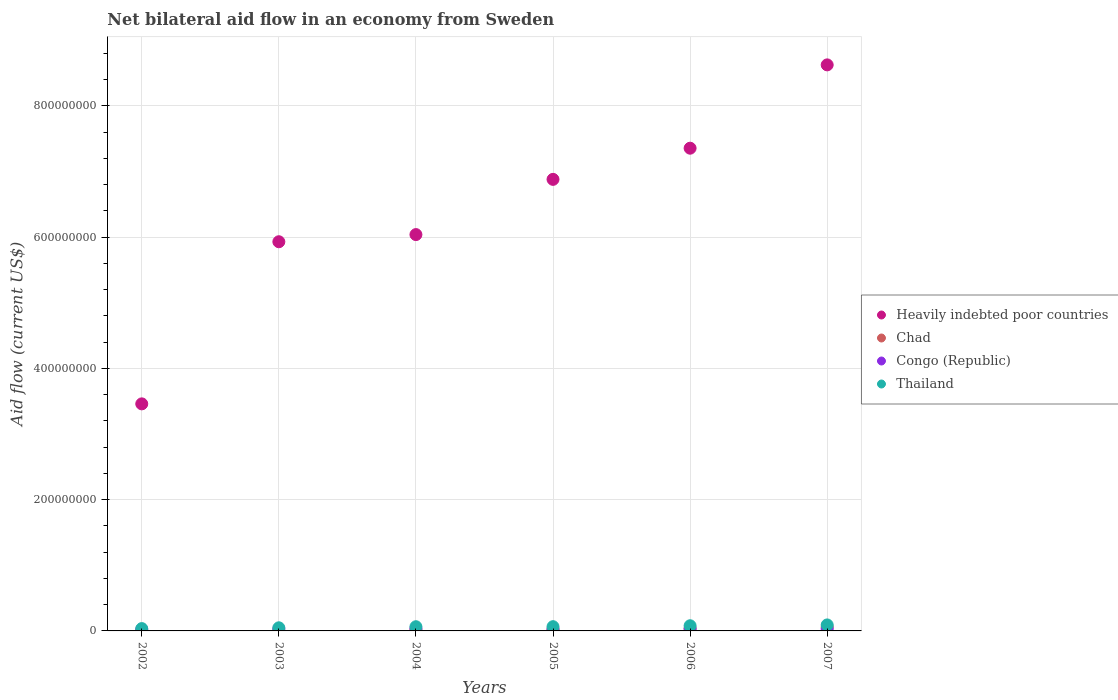How many different coloured dotlines are there?
Your answer should be very brief. 4. Is the number of dotlines equal to the number of legend labels?
Make the answer very short. No. What is the net bilateral aid flow in Chad in 2007?
Make the answer very short. 5.87e+06. Across all years, what is the maximum net bilateral aid flow in Congo (Republic)?
Make the answer very short. 3.56e+06. Across all years, what is the minimum net bilateral aid flow in Heavily indebted poor countries?
Give a very brief answer. 3.46e+08. In which year was the net bilateral aid flow in Congo (Republic) maximum?
Offer a very short reply. 2004. What is the total net bilateral aid flow in Chad in the graph?
Provide a short and direct response. 1.38e+07. What is the difference between the net bilateral aid flow in Congo (Republic) in 2002 and that in 2006?
Offer a very short reply. -1.04e+06. What is the difference between the net bilateral aid flow in Heavily indebted poor countries in 2003 and the net bilateral aid flow in Congo (Republic) in 2005?
Give a very brief answer. 5.91e+08. What is the average net bilateral aid flow in Heavily indebted poor countries per year?
Your response must be concise. 6.38e+08. In the year 2003, what is the difference between the net bilateral aid flow in Thailand and net bilateral aid flow in Heavily indebted poor countries?
Ensure brevity in your answer.  -5.88e+08. In how many years, is the net bilateral aid flow in Chad greater than 800000000 US$?
Offer a very short reply. 0. What is the ratio of the net bilateral aid flow in Congo (Republic) in 2005 to that in 2007?
Offer a terse response. 0.7. Is the net bilateral aid flow in Chad in 2003 less than that in 2006?
Your answer should be compact. Yes. Is the difference between the net bilateral aid flow in Thailand in 2006 and 2007 greater than the difference between the net bilateral aid flow in Heavily indebted poor countries in 2006 and 2007?
Offer a terse response. Yes. What is the difference between the highest and the second highest net bilateral aid flow in Thailand?
Your answer should be compact. 1.25e+06. What is the difference between the highest and the lowest net bilateral aid flow in Thailand?
Ensure brevity in your answer.  5.58e+06. Does the net bilateral aid flow in Chad monotonically increase over the years?
Your response must be concise. Yes. Is the net bilateral aid flow in Heavily indebted poor countries strictly less than the net bilateral aid flow in Congo (Republic) over the years?
Provide a short and direct response. No. How many years are there in the graph?
Provide a succinct answer. 6. Does the graph contain any zero values?
Your answer should be very brief. Yes. Does the graph contain grids?
Your answer should be compact. Yes. Where does the legend appear in the graph?
Give a very brief answer. Center right. How many legend labels are there?
Your response must be concise. 4. How are the legend labels stacked?
Keep it short and to the point. Vertical. What is the title of the graph?
Give a very brief answer. Net bilateral aid flow in an economy from Sweden. Does "Niger" appear as one of the legend labels in the graph?
Provide a short and direct response. No. What is the label or title of the X-axis?
Your answer should be very brief. Years. What is the label or title of the Y-axis?
Your answer should be compact. Aid flow (current US$). What is the Aid flow (current US$) of Heavily indebted poor countries in 2002?
Provide a succinct answer. 3.46e+08. What is the Aid flow (current US$) in Congo (Republic) in 2002?
Offer a very short reply. 2.16e+06. What is the Aid flow (current US$) of Thailand in 2002?
Keep it short and to the point. 3.55e+06. What is the Aid flow (current US$) in Heavily indebted poor countries in 2003?
Ensure brevity in your answer.  5.93e+08. What is the Aid flow (current US$) of Chad in 2003?
Keep it short and to the point. 3.10e+05. What is the Aid flow (current US$) of Congo (Republic) in 2003?
Keep it short and to the point. 3.02e+06. What is the Aid flow (current US$) in Thailand in 2003?
Provide a short and direct response. 4.76e+06. What is the Aid flow (current US$) in Heavily indebted poor countries in 2004?
Make the answer very short. 6.04e+08. What is the Aid flow (current US$) of Chad in 2004?
Offer a terse response. 1.49e+06. What is the Aid flow (current US$) of Congo (Republic) in 2004?
Keep it short and to the point. 3.56e+06. What is the Aid flow (current US$) in Thailand in 2004?
Give a very brief answer. 6.39e+06. What is the Aid flow (current US$) in Heavily indebted poor countries in 2005?
Offer a terse response. 6.88e+08. What is the Aid flow (current US$) of Chad in 2005?
Give a very brief answer. 2.47e+06. What is the Aid flow (current US$) in Congo (Republic) in 2005?
Your answer should be very brief. 2.22e+06. What is the Aid flow (current US$) of Thailand in 2005?
Your response must be concise. 6.47e+06. What is the Aid flow (current US$) of Heavily indebted poor countries in 2006?
Keep it short and to the point. 7.35e+08. What is the Aid flow (current US$) of Chad in 2006?
Your answer should be compact. 3.61e+06. What is the Aid flow (current US$) in Congo (Republic) in 2006?
Your answer should be very brief. 3.20e+06. What is the Aid flow (current US$) of Thailand in 2006?
Offer a very short reply. 7.88e+06. What is the Aid flow (current US$) of Heavily indebted poor countries in 2007?
Make the answer very short. 8.62e+08. What is the Aid flow (current US$) in Chad in 2007?
Give a very brief answer. 5.87e+06. What is the Aid flow (current US$) of Congo (Republic) in 2007?
Offer a very short reply. 3.15e+06. What is the Aid flow (current US$) in Thailand in 2007?
Offer a terse response. 9.13e+06. Across all years, what is the maximum Aid flow (current US$) of Heavily indebted poor countries?
Your answer should be compact. 8.62e+08. Across all years, what is the maximum Aid flow (current US$) in Chad?
Make the answer very short. 5.87e+06. Across all years, what is the maximum Aid flow (current US$) of Congo (Republic)?
Make the answer very short. 3.56e+06. Across all years, what is the maximum Aid flow (current US$) of Thailand?
Offer a terse response. 9.13e+06. Across all years, what is the minimum Aid flow (current US$) in Heavily indebted poor countries?
Ensure brevity in your answer.  3.46e+08. Across all years, what is the minimum Aid flow (current US$) of Congo (Republic)?
Offer a terse response. 2.16e+06. Across all years, what is the minimum Aid flow (current US$) of Thailand?
Your response must be concise. 3.55e+06. What is the total Aid flow (current US$) of Heavily indebted poor countries in the graph?
Your answer should be very brief. 3.83e+09. What is the total Aid flow (current US$) in Chad in the graph?
Your answer should be very brief. 1.38e+07. What is the total Aid flow (current US$) in Congo (Republic) in the graph?
Provide a short and direct response. 1.73e+07. What is the total Aid flow (current US$) in Thailand in the graph?
Give a very brief answer. 3.82e+07. What is the difference between the Aid flow (current US$) in Heavily indebted poor countries in 2002 and that in 2003?
Make the answer very short. -2.47e+08. What is the difference between the Aid flow (current US$) in Congo (Republic) in 2002 and that in 2003?
Your response must be concise. -8.60e+05. What is the difference between the Aid flow (current US$) in Thailand in 2002 and that in 2003?
Ensure brevity in your answer.  -1.21e+06. What is the difference between the Aid flow (current US$) in Heavily indebted poor countries in 2002 and that in 2004?
Give a very brief answer. -2.58e+08. What is the difference between the Aid flow (current US$) in Congo (Republic) in 2002 and that in 2004?
Offer a very short reply. -1.40e+06. What is the difference between the Aid flow (current US$) in Thailand in 2002 and that in 2004?
Provide a short and direct response. -2.84e+06. What is the difference between the Aid flow (current US$) in Heavily indebted poor countries in 2002 and that in 2005?
Make the answer very short. -3.42e+08. What is the difference between the Aid flow (current US$) of Thailand in 2002 and that in 2005?
Give a very brief answer. -2.92e+06. What is the difference between the Aid flow (current US$) in Heavily indebted poor countries in 2002 and that in 2006?
Make the answer very short. -3.89e+08. What is the difference between the Aid flow (current US$) in Congo (Republic) in 2002 and that in 2006?
Your answer should be very brief. -1.04e+06. What is the difference between the Aid flow (current US$) of Thailand in 2002 and that in 2006?
Your answer should be compact. -4.33e+06. What is the difference between the Aid flow (current US$) in Heavily indebted poor countries in 2002 and that in 2007?
Provide a short and direct response. -5.16e+08. What is the difference between the Aid flow (current US$) of Congo (Republic) in 2002 and that in 2007?
Offer a very short reply. -9.90e+05. What is the difference between the Aid flow (current US$) in Thailand in 2002 and that in 2007?
Your answer should be very brief. -5.58e+06. What is the difference between the Aid flow (current US$) in Heavily indebted poor countries in 2003 and that in 2004?
Ensure brevity in your answer.  -1.09e+07. What is the difference between the Aid flow (current US$) in Chad in 2003 and that in 2004?
Provide a succinct answer. -1.18e+06. What is the difference between the Aid flow (current US$) in Congo (Republic) in 2003 and that in 2004?
Your answer should be very brief. -5.40e+05. What is the difference between the Aid flow (current US$) of Thailand in 2003 and that in 2004?
Keep it short and to the point. -1.63e+06. What is the difference between the Aid flow (current US$) of Heavily indebted poor countries in 2003 and that in 2005?
Ensure brevity in your answer.  -9.50e+07. What is the difference between the Aid flow (current US$) in Chad in 2003 and that in 2005?
Make the answer very short. -2.16e+06. What is the difference between the Aid flow (current US$) in Congo (Republic) in 2003 and that in 2005?
Your response must be concise. 8.00e+05. What is the difference between the Aid flow (current US$) in Thailand in 2003 and that in 2005?
Provide a succinct answer. -1.71e+06. What is the difference between the Aid flow (current US$) of Heavily indebted poor countries in 2003 and that in 2006?
Ensure brevity in your answer.  -1.42e+08. What is the difference between the Aid flow (current US$) in Chad in 2003 and that in 2006?
Your answer should be very brief. -3.30e+06. What is the difference between the Aid flow (current US$) in Thailand in 2003 and that in 2006?
Keep it short and to the point. -3.12e+06. What is the difference between the Aid flow (current US$) in Heavily indebted poor countries in 2003 and that in 2007?
Provide a short and direct response. -2.69e+08. What is the difference between the Aid flow (current US$) of Chad in 2003 and that in 2007?
Provide a succinct answer. -5.56e+06. What is the difference between the Aid flow (current US$) of Thailand in 2003 and that in 2007?
Give a very brief answer. -4.37e+06. What is the difference between the Aid flow (current US$) in Heavily indebted poor countries in 2004 and that in 2005?
Provide a short and direct response. -8.41e+07. What is the difference between the Aid flow (current US$) in Chad in 2004 and that in 2005?
Your response must be concise. -9.80e+05. What is the difference between the Aid flow (current US$) in Congo (Republic) in 2004 and that in 2005?
Provide a succinct answer. 1.34e+06. What is the difference between the Aid flow (current US$) in Thailand in 2004 and that in 2005?
Your answer should be very brief. -8.00e+04. What is the difference between the Aid flow (current US$) of Heavily indebted poor countries in 2004 and that in 2006?
Your answer should be compact. -1.32e+08. What is the difference between the Aid flow (current US$) of Chad in 2004 and that in 2006?
Offer a very short reply. -2.12e+06. What is the difference between the Aid flow (current US$) in Congo (Republic) in 2004 and that in 2006?
Offer a very short reply. 3.60e+05. What is the difference between the Aid flow (current US$) in Thailand in 2004 and that in 2006?
Your response must be concise. -1.49e+06. What is the difference between the Aid flow (current US$) in Heavily indebted poor countries in 2004 and that in 2007?
Your response must be concise. -2.59e+08. What is the difference between the Aid flow (current US$) in Chad in 2004 and that in 2007?
Your answer should be compact. -4.38e+06. What is the difference between the Aid flow (current US$) in Thailand in 2004 and that in 2007?
Your answer should be compact. -2.74e+06. What is the difference between the Aid flow (current US$) in Heavily indebted poor countries in 2005 and that in 2006?
Give a very brief answer. -4.75e+07. What is the difference between the Aid flow (current US$) in Chad in 2005 and that in 2006?
Ensure brevity in your answer.  -1.14e+06. What is the difference between the Aid flow (current US$) of Congo (Republic) in 2005 and that in 2006?
Offer a terse response. -9.80e+05. What is the difference between the Aid flow (current US$) of Thailand in 2005 and that in 2006?
Your response must be concise. -1.41e+06. What is the difference between the Aid flow (current US$) in Heavily indebted poor countries in 2005 and that in 2007?
Make the answer very short. -1.74e+08. What is the difference between the Aid flow (current US$) of Chad in 2005 and that in 2007?
Keep it short and to the point. -3.40e+06. What is the difference between the Aid flow (current US$) of Congo (Republic) in 2005 and that in 2007?
Give a very brief answer. -9.30e+05. What is the difference between the Aid flow (current US$) in Thailand in 2005 and that in 2007?
Ensure brevity in your answer.  -2.66e+06. What is the difference between the Aid flow (current US$) of Heavily indebted poor countries in 2006 and that in 2007?
Your answer should be compact. -1.27e+08. What is the difference between the Aid flow (current US$) in Chad in 2006 and that in 2007?
Your answer should be very brief. -2.26e+06. What is the difference between the Aid flow (current US$) of Thailand in 2006 and that in 2007?
Your answer should be compact. -1.25e+06. What is the difference between the Aid flow (current US$) of Heavily indebted poor countries in 2002 and the Aid flow (current US$) of Chad in 2003?
Offer a terse response. 3.46e+08. What is the difference between the Aid flow (current US$) in Heavily indebted poor countries in 2002 and the Aid flow (current US$) in Congo (Republic) in 2003?
Offer a very short reply. 3.43e+08. What is the difference between the Aid flow (current US$) in Heavily indebted poor countries in 2002 and the Aid flow (current US$) in Thailand in 2003?
Offer a terse response. 3.41e+08. What is the difference between the Aid flow (current US$) in Congo (Republic) in 2002 and the Aid flow (current US$) in Thailand in 2003?
Ensure brevity in your answer.  -2.60e+06. What is the difference between the Aid flow (current US$) in Heavily indebted poor countries in 2002 and the Aid flow (current US$) in Chad in 2004?
Make the answer very short. 3.44e+08. What is the difference between the Aid flow (current US$) in Heavily indebted poor countries in 2002 and the Aid flow (current US$) in Congo (Republic) in 2004?
Offer a very short reply. 3.42e+08. What is the difference between the Aid flow (current US$) of Heavily indebted poor countries in 2002 and the Aid flow (current US$) of Thailand in 2004?
Offer a very short reply. 3.40e+08. What is the difference between the Aid flow (current US$) of Congo (Republic) in 2002 and the Aid flow (current US$) of Thailand in 2004?
Provide a succinct answer. -4.23e+06. What is the difference between the Aid flow (current US$) of Heavily indebted poor countries in 2002 and the Aid flow (current US$) of Chad in 2005?
Give a very brief answer. 3.43e+08. What is the difference between the Aid flow (current US$) in Heavily indebted poor countries in 2002 and the Aid flow (current US$) in Congo (Republic) in 2005?
Your response must be concise. 3.44e+08. What is the difference between the Aid flow (current US$) in Heavily indebted poor countries in 2002 and the Aid flow (current US$) in Thailand in 2005?
Your response must be concise. 3.39e+08. What is the difference between the Aid flow (current US$) of Congo (Republic) in 2002 and the Aid flow (current US$) of Thailand in 2005?
Make the answer very short. -4.31e+06. What is the difference between the Aid flow (current US$) of Heavily indebted poor countries in 2002 and the Aid flow (current US$) of Chad in 2006?
Offer a terse response. 3.42e+08. What is the difference between the Aid flow (current US$) of Heavily indebted poor countries in 2002 and the Aid flow (current US$) of Congo (Republic) in 2006?
Offer a very short reply. 3.43e+08. What is the difference between the Aid flow (current US$) in Heavily indebted poor countries in 2002 and the Aid flow (current US$) in Thailand in 2006?
Offer a very short reply. 3.38e+08. What is the difference between the Aid flow (current US$) of Congo (Republic) in 2002 and the Aid flow (current US$) of Thailand in 2006?
Ensure brevity in your answer.  -5.72e+06. What is the difference between the Aid flow (current US$) of Heavily indebted poor countries in 2002 and the Aid flow (current US$) of Chad in 2007?
Make the answer very short. 3.40e+08. What is the difference between the Aid flow (current US$) of Heavily indebted poor countries in 2002 and the Aid flow (current US$) of Congo (Republic) in 2007?
Provide a succinct answer. 3.43e+08. What is the difference between the Aid flow (current US$) in Heavily indebted poor countries in 2002 and the Aid flow (current US$) in Thailand in 2007?
Keep it short and to the point. 3.37e+08. What is the difference between the Aid flow (current US$) of Congo (Republic) in 2002 and the Aid flow (current US$) of Thailand in 2007?
Your answer should be compact. -6.97e+06. What is the difference between the Aid flow (current US$) of Heavily indebted poor countries in 2003 and the Aid flow (current US$) of Chad in 2004?
Your answer should be compact. 5.91e+08. What is the difference between the Aid flow (current US$) in Heavily indebted poor countries in 2003 and the Aid flow (current US$) in Congo (Republic) in 2004?
Give a very brief answer. 5.89e+08. What is the difference between the Aid flow (current US$) of Heavily indebted poor countries in 2003 and the Aid flow (current US$) of Thailand in 2004?
Make the answer very short. 5.86e+08. What is the difference between the Aid flow (current US$) in Chad in 2003 and the Aid flow (current US$) in Congo (Republic) in 2004?
Keep it short and to the point. -3.25e+06. What is the difference between the Aid flow (current US$) in Chad in 2003 and the Aid flow (current US$) in Thailand in 2004?
Give a very brief answer. -6.08e+06. What is the difference between the Aid flow (current US$) of Congo (Republic) in 2003 and the Aid flow (current US$) of Thailand in 2004?
Provide a short and direct response. -3.37e+06. What is the difference between the Aid flow (current US$) in Heavily indebted poor countries in 2003 and the Aid flow (current US$) in Chad in 2005?
Give a very brief answer. 5.90e+08. What is the difference between the Aid flow (current US$) of Heavily indebted poor countries in 2003 and the Aid flow (current US$) of Congo (Republic) in 2005?
Make the answer very short. 5.91e+08. What is the difference between the Aid flow (current US$) in Heavily indebted poor countries in 2003 and the Aid flow (current US$) in Thailand in 2005?
Your answer should be very brief. 5.86e+08. What is the difference between the Aid flow (current US$) in Chad in 2003 and the Aid flow (current US$) in Congo (Republic) in 2005?
Ensure brevity in your answer.  -1.91e+06. What is the difference between the Aid flow (current US$) in Chad in 2003 and the Aid flow (current US$) in Thailand in 2005?
Ensure brevity in your answer.  -6.16e+06. What is the difference between the Aid flow (current US$) in Congo (Republic) in 2003 and the Aid flow (current US$) in Thailand in 2005?
Provide a short and direct response. -3.45e+06. What is the difference between the Aid flow (current US$) in Heavily indebted poor countries in 2003 and the Aid flow (current US$) in Chad in 2006?
Your response must be concise. 5.89e+08. What is the difference between the Aid flow (current US$) of Heavily indebted poor countries in 2003 and the Aid flow (current US$) of Congo (Republic) in 2006?
Ensure brevity in your answer.  5.90e+08. What is the difference between the Aid flow (current US$) of Heavily indebted poor countries in 2003 and the Aid flow (current US$) of Thailand in 2006?
Offer a very short reply. 5.85e+08. What is the difference between the Aid flow (current US$) of Chad in 2003 and the Aid flow (current US$) of Congo (Republic) in 2006?
Ensure brevity in your answer.  -2.89e+06. What is the difference between the Aid flow (current US$) of Chad in 2003 and the Aid flow (current US$) of Thailand in 2006?
Provide a short and direct response. -7.57e+06. What is the difference between the Aid flow (current US$) in Congo (Republic) in 2003 and the Aid flow (current US$) in Thailand in 2006?
Ensure brevity in your answer.  -4.86e+06. What is the difference between the Aid flow (current US$) in Heavily indebted poor countries in 2003 and the Aid flow (current US$) in Chad in 2007?
Your answer should be compact. 5.87e+08. What is the difference between the Aid flow (current US$) of Heavily indebted poor countries in 2003 and the Aid flow (current US$) of Congo (Republic) in 2007?
Make the answer very short. 5.90e+08. What is the difference between the Aid flow (current US$) in Heavily indebted poor countries in 2003 and the Aid flow (current US$) in Thailand in 2007?
Provide a succinct answer. 5.84e+08. What is the difference between the Aid flow (current US$) of Chad in 2003 and the Aid flow (current US$) of Congo (Republic) in 2007?
Your answer should be compact. -2.84e+06. What is the difference between the Aid flow (current US$) of Chad in 2003 and the Aid flow (current US$) of Thailand in 2007?
Provide a short and direct response. -8.82e+06. What is the difference between the Aid flow (current US$) of Congo (Republic) in 2003 and the Aid flow (current US$) of Thailand in 2007?
Your answer should be compact. -6.11e+06. What is the difference between the Aid flow (current US$) of Heavily indebted poor countries in 2004 and the Aid flow (current US$) of Chad in 2005?
Give a very brief answer. 6.01e+08. What is the difference between the Aid flow (current US$) of Heavily indebted poor countries in 2004 and the Aid flow (current US$) of Congo (Republic) in 2005?
Offer a terse response. 6.02e+08. What is the difference between the Aid flow (current US$) in Heavily indebted poor countries in 2004 and the Aid flow (current US$) in Thailand in 2005?
Your response must be concise. 5.97e+08. What is the difference between the Aid flow (current US$) in Chad in 2004 and the Aid flow (current US$) in Congo (Republic) in 2005?
Offer a very short reply. -7.30e+05. What is the difference between the Aid flow (current US$) in Chad in 2004 and the Aid flow (current US$) in Thailand in 2005?
Ensure brevity in your answer.  -4.98e+06. What is the difference between the Aid flow (current US$) of Congo (Republic) in 2004 and the Aid flow (current US$) of Thailand in 2005?
Give a very brief answer. -2.91e+06. What is the difference between the Aid flow (current US$) in Heavily indebted poor countries in 2004 and the Aid flow (current US$) in Chad in 2006?
Give a very brief answer. 6.00e+08. What is the difference between the Aid flow (current US$) in Heavily indebted poor countries in 2004 and the Aid flow (current US$) in Congo (Republic) in 2006?
Your response must be concise. 6.01e+08. What is the difference between the Aid flow (current US$) in Heavily indebted poor countries in 2004 and the Aid flow (current US$) in Thailand in 2006?
Provide a short and direct response. 5.96e+08. What is the difference between the Aid flow (current US$) of Chad in 2004 and the Aid flow (current US$) of Congo (Republic) in 2006?
Ensure brevity in your answer.  -1.71e+06. What is the difference between the Aid flow (current US$) in Chad in 2004 and the Aid flow (current US$) in Thailand in 2006?
Your response must be concise. -6.39e+06. What is the difference between the Aid flow (current US$) of Congo (Republic) in 2004 and the Aid flow (current US$) of Thailand in 2006?
Your answer should be very brief. -4.32e+06. What is the difference between the Aid flow (current US$) in Heavily indebted poor countries in 2004 and the Aid flow (current US$) in Chad in 2007?
Keep it short and to the point. 5.98e+08. What is the difference between the Aid flow (current US$) in Heavily indebted poor countries in 2004 and the Aid flow (current US$) in Congo (Republic) in 2007?
Provide a succinct answer. 6.01e+08. What is the difference between the Aid flow (current US$) in Heavily indebted poor countries in 2004 and the Aid flow (current US$) in Thailand in 2007?
Your response must be concise. 5.95e+08. What is the difference between the Aid flow (current US$) of Chad in 2004 and the Aid flow (current US$) of Congo (Republic) in 2007?
Offer a very short reply. -1.66e+06. What is the difference between the Aid flow (current US$) in Chad in 2004 and the Aid flow (current US$) in Thailand in 2007?
Offer a very short reply. -7.64e+06. What is the difference between the Aid flow (current US$) in Congo (Republic) in 2004 and the Aid flow (current US$) in Thailand in 2007?
Make the answer very short. -5.57e+06. What is the difference between the Aid flow (current US$) of Heavily indebted poor countries in 2005 and the Aid flow (current US$) of Chad in 2006?
Your answer should be compact. 6.84e+08. What is the difference between the Aid flow (current US$) of Heavily indebted poor countries in 2005 and the Aid flow (current US$) of Congo (Republic) in 2006?
Make the answer very short. 6.85e+08. What is the difference between the Aid flow (current US$) in Heavily indebted poor countries in 2005 and the Aid flow (current US$) in Thailand in 2006?
Ensure brevity in your answer.  6.80e+08. What is the difference between the Aid flow (current US$) in Chad in 2005 and the Aid flow (current US$) in Congo (Republic) in 2006?
Make the answer very short. -7.30e+05. What is the difference between the Aid flow (current US$) of Chad in 2005 and the Aid flow (current US$) of Thailand in 2006?
Your answer should be compact. -5.41e+06. What is the difference between the Aid flow (current US$) of Congo (Republic) in 2005 and the Aid flow (current US$) of Thailand in 2006?
Your answer should be very brief. -5.66e+06. What is the difference between the Aid flow (current US$) of Heavily indebted poor countries in 2005 and the Aid flow (current US$) of Chad in 2007?
Your answer should be compact. 6.82e+08. What is the difference between the Aid flow (current US$) in Heavily indebted poor countries in 2005 and the Aid flow (current US$) in Congo (Republic) in 2007?
Your response must be concise. 6.85e+08. What is the difference between the Aid flow (current US$) in Heavily indebted poor countries in 2005 and the Aid flow (current US$) in Thailand in 2007?
Ensure brevity in your answer.  6.79e+08. What is the difference between the Aid flow (current US$) of Chad in 2005 and the Aid flow (current US$) of Congo (Republic) in 2007?
Offer a terse response. -6.80e+05. What is the difference between the Aid flow (current US$) in Chad in 2005 and the Aid flow (current US$) in Thailand in 2007?
Make the answer very short. -6.66e+06. What is the difference between the Aid flow (current US$) in Congo (Republic) in 2005 and the Aid flow (current US$) in Thailand in 2007?
Your answer should be compact. -6.91e+06. What is the difference between the Aid flow (current US$) of Heavily indebted poor countries in 2006 and the Aid flow (current US$) of Chad in 2007?
Your answer should be compact. 7.30e+08. What is the difference between the Aid flow (current US$) of Heavily indebted poor countries in 2006 and the Aid flow (current US$) of Congo (Republic) in 2007?
Your response must be concise. 7.32e+08. What is the difference between the Aid flow (current US$) of Heavily indebted poor countries in 2006 and the Aid flow (current US$) of Thailand in 2007?
Your response must be concise. 7.26e+08. What is the difference between the Aid flow (current US$) of Chad in 2006 and the Aid flow (current US$) of Thailand in 2007?
Ensure brevity in your answer.  -5.52e+06. What is the difference between the Aid flow (current US$) of Congo (Republic) in 2006 and the Aid flow (current US$) of Thailand in 2007?
Make the answer very short. -5.93e+06. What is the average Aid flow (current US$) in Heavily indebted poor countries per year?
Make the answer very short. 6.38e+08. What is the average Aid flow (current US$) of Chad per year?
Keep it short and to the point. 2.29e+06. What is the average Aid flow (current US$) of Congo (Republic) per year?
Give a very brief answer. 2.88e+06. What is the average Aid flow (current US$) in Thailand per year?
Offer a very short reply. 6.36e+06. In the year 2002, what is the difference between the Aid flow (current US$) in Heavily indebted poor countries and Aid flow (current US$) in Congo (Republic)?
Your answer should be very brief. 3.44e+08. In the year 2002, what is the difference between the Aid flow (current US$) in Heavily indebted poor countries and Aid flow (current US$) in Thailand?
Your answer should be compact. 3.42e+08. In the year 2002, what is the difference between the Aid flow (current US$) in Congo (Republic) and Aid flow (current US$) in Thailand?
Your answer should be compact. -1.39e+06. In the year 2003, what is the difference between the Aid flow (current US$) in Heavily indebted poor countries and Aid flow (current US$) in Chad?
Give a very brief answer. 5.93e+08. In the year 2003, what is the difference between the Aid flow (current US$) in Heavily indebted poor countries and Aid flow (current US$) in Congo (Republic)?
Your answer should be compact. 5.90e+08. In the year 2003, what is the difference between the Aid flow (current US$) in Heavily indebted poor countries and Aid flow (current US$) in Thailand?
Provide a short and direct response. 5.88e+08. In the year 2003, what is the difference between the Aid flow (current US$) of Chad and Aid flow (current US$) of Congo (Republic)?
Keep it short and to the point. -2.71e+06. In the year 2003, what is the difference between the Aid flow (current US$) in Chad and Aid flow (current US$) in Thailand?
Offer a terse response. -4.45e+06. In the year 2003, what is the difference between the Aid flow (current US$) of Congo (Republic) and Aid flow (current US$) of Thailand?
Give a very brief answer. -1.74e+06. In the year 2004, what is the difference between the Aid flow (current US$) in Heavily indebted poor countries and Aid flow (current US$) in Chad?
Make the answer very short. 6.02e+08. In the year 2004, what is the difference between the Aid flow (current US$) in Heavily indebted poor countries and Aid flow (current US$) in Congo (Republic)?
Your answer should be very brief. 6.00e+08. In the year 2004, what is the difference between the Aid flow (current US$) in Heavily indebted poor countries and Aid flow (current US$) in Thailand?
Give a very brief answer. 5.97e+08. In the year 2004, what is the difference between the Aid flow (current US$) in Chad and Aid flow (current US$) in Congo (Republic)?
Provide a short and direct response. -2.07e+06. In the year 2004, what is the difference between the Aid flow (current US$) in Chad and Aid flow (current US$) in Thailand?
Offer a terse response. -4.90e+06. In the year 2004, what is the difference between the Aid flow (current US$) in Congo (Republic) and Aid flow (current US$) in Thailand?
Give a very brief answer. -2.83e+06. In the year 2005, what is the difference between the Aid flow (current US$) in Heavily indebted poor countries and Aid flow (current US$) in Chad?
Provide a succinct answer. 6.85e+08. In the year 2005, what is the difference between the Aid flow (current US$) of Heavily indebted poor countries and Aid flow (current US$) of Congo (Republic)?
Your answer should be compact. 6.86e+08. In the year 2005, what is the difference between the Aid flow (current US$) of Heavily indebted poor countries and Aid flow (current US$) of Thailand?
Provide a short and direct response. 6.81e+08. In the year 2005, what is the difference between the Aid flow (current US$) of Chad and Aid flow (current US$) of Congo (Republic)?
Keep it short and to the point. 2.50e+05. In the year 2005, what is the difference between the Aid flow (current US$) of Chad and Aid flow (current US$) of Thailand?
Ensure brevity in your answer.  -4.00e+06. In the year 2005, what is the difference between the Aid flow (current US$) of Congo (Republic) and Aid flow (current US$) of Thailand?
Provide a short and direct response. -4.25e+06. In the year 2006, what is the difference between the Aid flow (current US$) in Heavily indebted poor countries and Aid flow (current US$) in Chad?
Provide a succinct answer. 7.32e+08. In the year 2006, what is the difference between the Aid flow (current US$) in Heavily indebted poor countries and Aid flow (current US$) in Congo (Republic)?
Your answer should be compact. 7.32e+08. In the year 2006, what is the difference between the Aid flow (current US$) in Heavily indebted poor countries and Aid flow (current US$) in Thailand?
Your response must be concise. 7.28e+08. In the year 2006, what is the difference between the Aid flow (current US$) of Chad and Aid flow (current US$) of Thailand?
Provide a succinct answer. -4.27e+06. In the year 2006, what is the difference between the Aid flow (current US$) of Congo (Republic) and Aid flow (current US$) of Thailand?
Provide a succinct answer. -4.68e+06. In the year 2007, what is the difference between the Aid flow (current US$) of Heavily indebted poor countries and Aid flow (current US$) of Chad?
Keep it short and to the point. 8.56e+08. In the year 2007, what is the difference between the Aid flow (current US$) of Heavily indebted poor countries and Aid flow (current US$) of Congo (Republic)?
Make the answer very short. 8.59e+08. In the year 2007, what is the difference between the Aid flow (current US$) in Heavily indebted poor countries and Aid flow (current US$) in Thailand?
Offer a terse response. 8.53e+08. In the year 2007, what is the difference between the Aid flow (current US$) in Chad and Aid flow (current US$) in Congo (Republic)?
Ensure brevity in your answer.  2.72e+06. In the year 2007, what is the difference between the Aid flow (current US$) in Chad and Aid flow (current US$) in Thailand?
Ensure brevity in your answer.  -3.26e+06. In the year 2007, what is the difference between the Aid flow (current US$) of Congo (Republic) and Aid flow (current US$) of Thailand?
Give a very brief answer. -5.98e+06. What is the ratio of the Aid flow (current US$) of Heavily indebted poor countries in 2002 to that in 2003?
Provide a short and direct response. 0.58. What is the ratio of the Aid flow (current US$) in Congo (Republic) in 2002 to that in 2003?
Provide a succinct answer. 0.72. What is the ratio of the Aid flow (current US$) of Thailand in 2002 to that in 2003?
Provide a succinct answer. 0.75. What is the ratio of the Aid flow (current US$) of Heavily indebted poor countries in 2002 to that in 2004?
Your answer should be compact. 0.57. What is the ratio of the Aid flow (current US$) in Congo (Republic) in 2002 to that in 2004?
Give a very brief answer. 0.61. What is the ratio of the Aid flow (current US$) of Thailand in 2002 to that in 2004?
Your answer should be compact. 0.56. What is the ratio of the Aid flow (current US$) of Heavily indebted poor countries in 2002 to that in 2005?
Give a very brief answer. 0.5. What is the ratio of the Aid flow (current US$) in Congo (Republic) in 2002 to that in 2005?
Ensure brevity in your answer.  0.97. What is the ratio of the Aid flow (current US$) of Thailand in 2002 to that in 2005?
Ensure brevity in your answer.  0.55. What is the ratio of the Aid flow (current US$) in Heavily indebted poor countries in 2002 to that in 2006?
Keep it short and to the point. 0.47. What is the ratio of the Aid flow (current US$) in Congo (Republic) in 2002 to that in 2006?
Give a very brief answer. 0.68. What is the ratio of the Aid flow (current US$) in Thailand in 2002 to that in 2006?
Offer a terse response. 0.45. What is the ratio of the Aid flow (current US$) of Heavily indebted poor countries in 2002 to that in 2007?
Keep it short and to the point. 0.4. What is the ratio of the Aid flow (current US$) of Congo (Republic) in 2002 to that in 2007?
Make the answer very short. 0.69. What is the ratio of the Aid flow (current US$) in Thailand in 2002 to that in 2007?
Offer a very short reply. 0.39. What is the ratio of the Aid flow (current US$) in Heavily indebted poor countries in 2003 to that in 2004?
Ensure brevity in your answer.  0.98. What is the ratio of the Aid flow (current US$) in Chad in 2003 to that in 2004?
Offer a terse response. 0.21. What is the ratio of the Aid flow (current US$) of Congo (Republic) in 2003 to that in 2004?
Make the answer very short. 0.85. What is the ratio of the Aid flow (current US$) in Thailand in 2003 to that in 2004?
Offer a terse response. 0.74. What is the ratio of the Aid flow (current US$) of Heavily indebted poor countries in 2003 to that in 2005?
Provide a succinct answer. 0.86. What is the ratio of the Aid flow (current US$) of Chad in 2003 to that in 2005?
Provide a succinct answer. 0.13. What is the ratio of the Aid flow (current US$) of Congo (Republic) in 2003 to that in 2005?
Make the answer very short. 1.36. What is the ratio of the Aid flow (current US$) of Thailand in 2003 to that in 2005?
Offer a very short reply. 0.74. What is the ratio of the Aid flow (current US$) of Heavily indebted poor countries in 2003 to that in 2006?
Offer a terse response. 0.81. What is the ratio of the Aid flow (current US$) in Chad in 2003 to that in 2006?
Your answer should be very brief. 0.09. What is the ratio of the Aid flow (current US$) of Congo (Republic) in 2003 to that in 2006?
Keep it short and to the point. 0.94. What is the ratio of the Aid flow (current US$) of Thailand in 2003 to that in 2006?
Provide a short and direct response. 0.6. What is the ratio of the Aid flow (current US$) of Heavily indebted poor countries in 2003 to that in 2007?
Give a very brief answer. 0.69. What is the ratio of the Aid flow (current US$) of Chad in 2003 to that in 2007?
Keep it short and to the point. 0.05. What is the ratio of the Aid flow (current US$) of Congo (Republic) in 2003 to that in 2007?
Offer a terse response. 0.96. What is the ratio of the Aid flow (current US$) of Thailand in 2003 to that in 2007?
Ensure brevity in your answer.  0.52. What is the ratio of the Aid flow (current US$) of Heavily indebted poor countries in 2004 to that in 2005?
Provide a short and direct response. 0.88. What is the ratio of the Aid flow (current US$) of Chad in 2004 to that in 2005?
Your answer should be compact. 0.6. What is the ratio of the Aid flow (current US$) of Congo (Republic) in 2004 to that in 2005?
Provide a short and direct response. 1.6. What is the ratio of the Aid flow (current US$) of Thailand in 2004 to that in 2005?
Offer a terse response. 0.99. What is the ratio of the Aid flow (current US$) in Heavily indebted poor countries in 2004 to that in 2006?
Provide a short and direct response. 0.82. What is the ratio of the Aid flow (current US$) in Chad in 2004 to that in 2006?
Provide a short and direct response. 0.41. What is the ratio of the Aid flow (current US$) of Congo (Republic) in 2004 to that in 2006?
Offer a very short reply. 1.11. What is the ratio of the Aid flow (current US$) in Thailand in 2004 to that in 2006?
Your answer should be compact. 0.81. What is the ratio of the Aid flow (current US$) in Heavily indebted poor countries in 2004 to that in 2007?
Your response must be concise. 0.7. What is the ratio of the Aid flow (current US$) of Chad in 2004 to that in 2007?
Your answer should be very brief. 0.25. What is the ratio of the Aid flow (current US$) of Congo (Republic) in 2004 to that in 2007?
Your answer should be very brief. 1.13. What is the ratio of the Aid flow (current US$) of Thailand in 2004 to that in 2007?
Your answer should be very brief. 0.7. What is the ratio of the Aid flow (current US$) in Heavily indebted poor countries in 2005 to that in 2006?
Make the answer very short. 0.94. What is the ratio of the Aid flow (current US$) in Chad in 2005 to that in 2006?
Keep it short and to the point. 0.68. What is the ratio of the Aid flow (current US$) in Congo (Republic) in 2005 to that in 2006?
Your answer should be very brief. 0.69. What is the ratio of the Aid flow (current US$) of Thailand in 2005 to that in 2006?
Your answer should be compact. 0.82. What is the ratio of the Aid flow (current US$) of Heavily indebted poor countries in 2005 to that in 2007?
Your response must be concise. 0.8. What is the ratio of the Aid flow (current US$) in Chad in 2005 to that in 2007?
Your answer should be very brief. 0.42. What is the ratio of the Aid flow (current US$) of Congo (Republic) in 2005 to that in 2007?
Keep it short and to the point. 0.7. What is the ratio of the Aid flow (current US$) in Thailand in 2005 to that in 2007?
Offer a very short reply. 0.71. What is the ratio of the Aid flow (current US$) of Heavily indebted poor countries in 2006 to that in 2007?
Offer a terse response. 0.85. What is the ratio of the Aid flow (current US$) of Chad in 2006 to that in 2007?
Offer a terse response. 0.61. What is the ratio of the Aid flow (current US$) in Congo (Republic) in 2006 to that in 2007?
Give a very brief answer. 1.02. What is the ratio of the Aid flow (current US$) in Thailand in 2006 to that in 2007?
Ensure brevity in your answer.  0.86. What is the difference between the highest and the second highest Aid flow (current US$) of Heavily indebted poor countries?
Make the answer very short. 1.27e+08. What is the difference between the highest and the second highest Aid flow (current US$) of Chad?
Give a very brief answer. 2.26e+06. What is the difference between the highest and the second highest Aid flow (current US$) of Congo (Republic)?
Your answer should be very brief. 3.60e+05. What is the difference between the highest and the second highest Aid flow (current US$) in Thailand?
Offer a very short reply. 1.25e+06. What is the difference between the highest and the lowest Aid flow (current US$) in Heavily indebted poor countries?
Your answer should be very brief. 5.16e+08. What is the difference between the highest and the lowest Aid flow (current US$) of Chad?
Provide a succinct answer. 5.87e+06. What is the difference between the highest and the lowest Aid flow (current US$) of Congo (Republic)?
Offer a terse response. 1.40e+06. What is the difference between the highest and the lowest Aid flow (current US$) in Thailand?
Your answer should be very brief. 5.58e+06. 